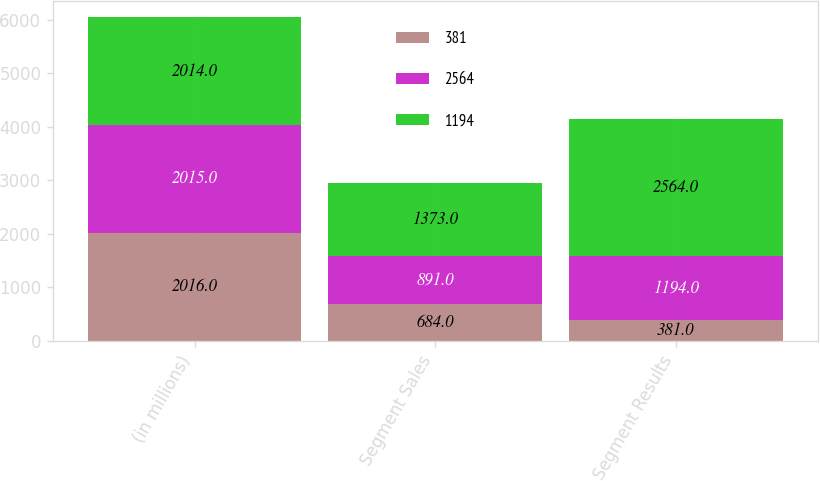<chart> <loc_0><loc_0><loc_500><loc_500><stacked_bar_chart><ecel><fcel>(in millions)<fcel>Segment Sales<fcel>Segment Results<nl><fcel>381<fcel>2016<fcel>684<fcel>381<nl><fcel>2564<fcel>2015<fcel>891<fcel>1194<nl><fcel>1194<fcel>2014<fcel>1373<fcel>2564<nl></chart> 